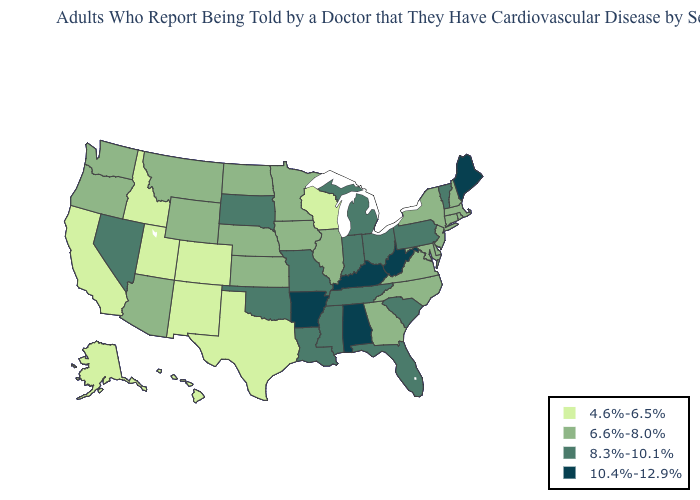What is the highest value in states that border Georgia?
Write a very short answer. 10.4%-12.9%. What is the value of Nevada?
Concise answer only. 8.3%-10.1%. Name the states that have a value in the range 8.3%-10.1%?
Write a very short answer. Florida, Indiana, Louisiana, Michigan, Mississippi, Missouri, Nevada, Ohio, Oklahoma, Pennsylvania, South Carolina, South Dakota, Tennessee, Vermont. What is the value of Pennsylvania?
Write a very short answer. 8.3%-10.1%. Does the map have missing data?
Keep it brief. No. What is the highest value in states that border Delaware?
Concise answer only. 8.3%-10.1%. Does the map have missing data?
Short answer required. No. What is the value of North Carolina?
Concise answer only. 6.6%-8.0%. What is the value of Delaware?
Concise answer only. 6.6%-8.0%. Among the states that border Colorado , which have the highest value?
Be succinct. Oklahoma. What is the value of Maine?
Quick response, please. 10.4%-12.9%. Does the map have missing data?
Quick response, please. No. What is the value of New Mexico?
Write a very short answer. 4.6%-6.5%. What is the value of Michigan?
Give a very brief answer. 8.3%-10.1%. Which states have the lowest value in the West?
Quick response, please. Alaska, California, Colorado, Hawaii, Idaho, New Mexico, Utah. 